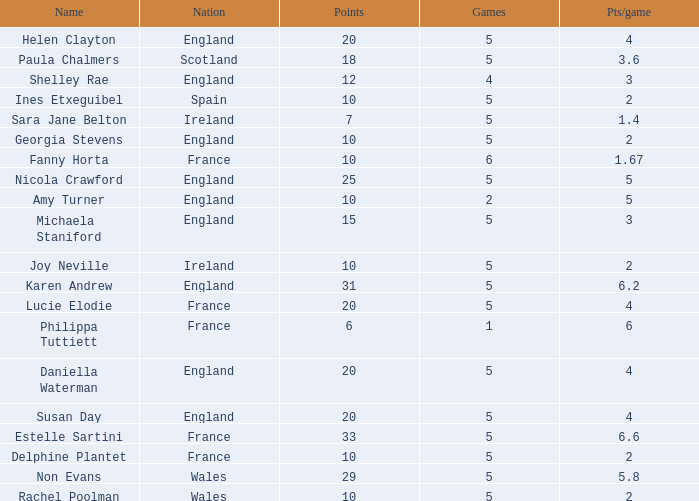Can you tell me the average Points that has a Pts/game larger than 4, and the Nation of england, and the Games smaller than 5? 10.0. Can you parse all the data within this table? {'header': ['Name', 'Nation', 'Points', 'Games', 'Pts/game'], 'rows': [['Helen Clayton', 'England', '20', '5', '4'], ['Paula Chalmers', 'Scotland', '18', '5', '3.6'], ['Shelley Rae', 'England', '12', '4', '3'], ['Ines Etxeguibel', 'Spain', '10', '5', '2'], ['Sara Jane Belton', 'Ireland', '7', '5', '1.4'], ['Georgia Stevens', 'England', '10', '5', '2'], ['Fanny Horta', 'France', '10', '6', '1.67'], ['Nicola Crawford', 'England', '25', '5', '5'], ['Amy Turner', 'England', '10', '2', '5'], ['Michaela Staniford', 'England', '15', '5', '3'], ['Joy Neville', 'Ireland', '10', '5', '2'], ['Karen Andrew', 'England', '31', '5', '6.2'], ['Lucie Elodie', 'France', '20', '5', '4'], ['Philippa Tuttiett', 'France', '6', '1', '6'], ['Daniella Waterman', 'England', '20', '5', '4'], ['Susan Day', 'England', '20', '5', '4'], ['Estelle Sartini', 'France', '33', '5', '6.6'], ['Delphine Plantet', 'France', '10', '5', '2'], ['Non Evans', 'Wales', '29', '5', '5.8'], ['Rachel Poolman', 'Wales', '10', '5', '2']]} 